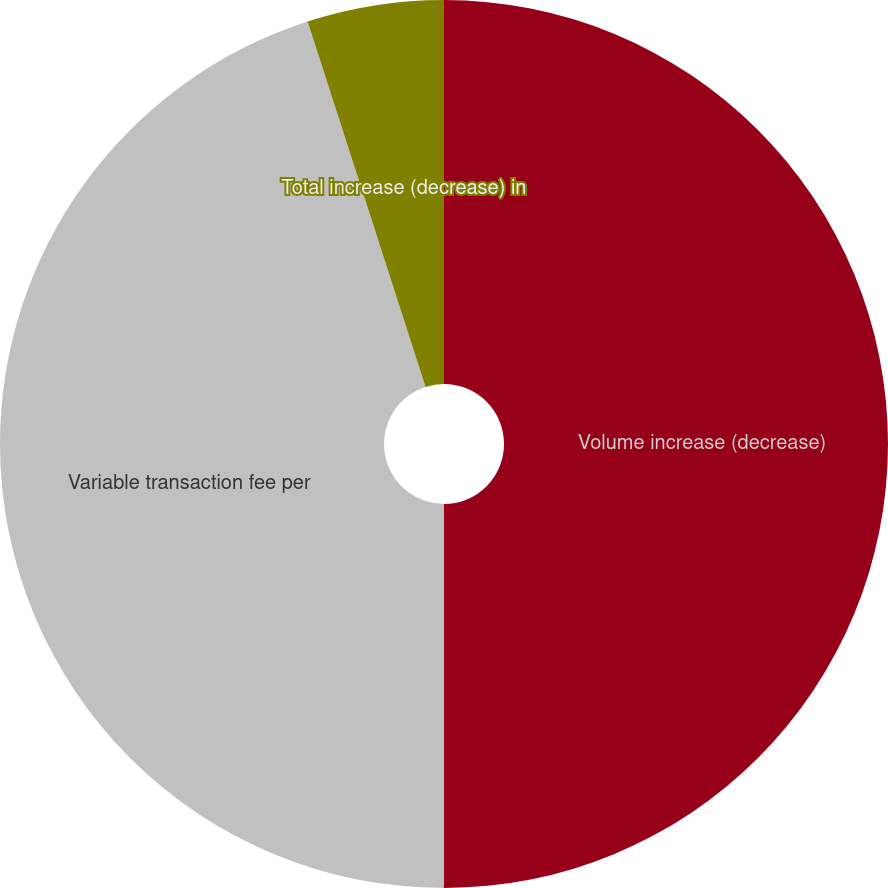Convert chart. <chart><loc_0><loc_0><loc_500><loc_500><pie_chart><fcel>Volume increase (decrease)<fcel>Variable transaction fee per<fcel>Total increase (decrease) in<nl><fcel>50.0%<fcel>45.03%<fcel>4.97%<nl></chart> 